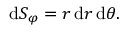Convert formula to latex. <formula><loc_0><loc_0><loc_500><loc_500>d S _ { \varphi } = r \, d r \, d \theta .</formula> 